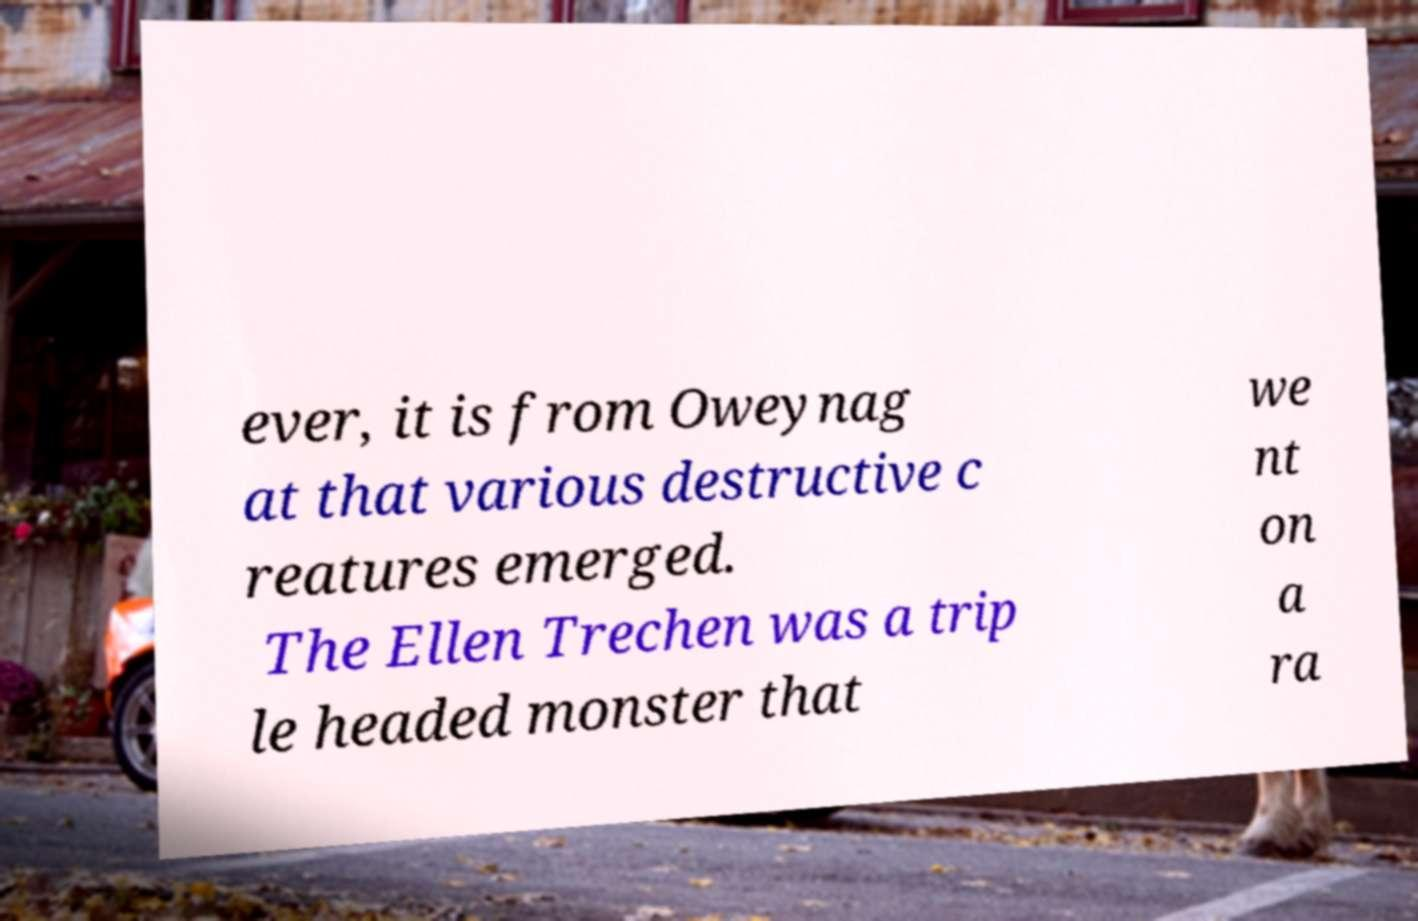Please identify and transcribe the text found in this image. ever, it is from Oweynag at that various destructive c reatures emerged. The Ellen Trechen was a trip le headed monster that we nt on a ra 